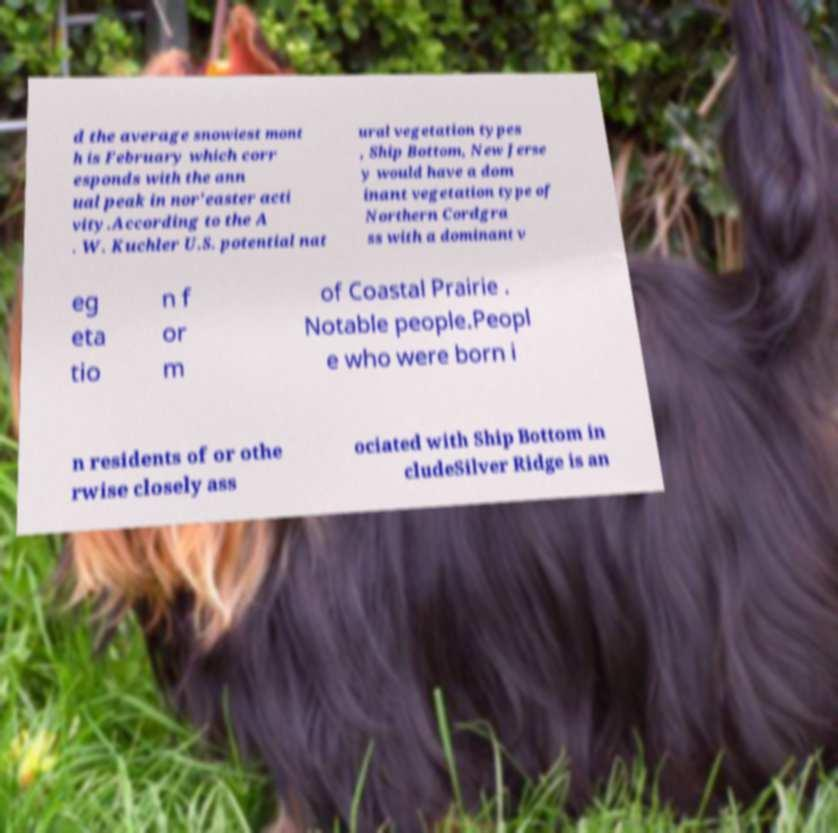Please identify and transcribe the text found in this image. d the average snowiest mont h is February which corr esponds with the ann ual peak in nor'easter acti vity.According to the A . W. Kuchler U.S. potential nat ural vegetation types , Ship Bottom, New Jerse y would have a dom inant vegetation type of Northern Cordgra ss with a dominant v eg eta tio n f or m of Coastal Prairie . Notable people.Peopl e who were born i n residents of or othe rwise closely ass ociated with Ship Bottom in cludeSilver Ridge is an 